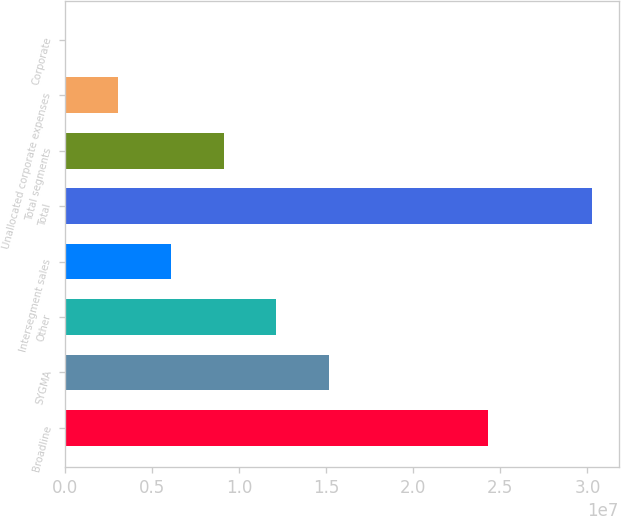Convert chart to OTSL. <chart><loc_0><loc_0><loc_500><loc_500><bar_chart><fcel>Broadline<fcel>SYGMA<fcel>Other<fcel>Intersegment sales<fcel>Total<fcel>Total segments<fcel>Unallocated corporate expenses<fcel>Corporate<nl><fcel>2.4267e+07<fcel>1.51597e+07<fcel>1.21353e+07<fcel>6.08642e+06<fcel>3.02819e+07<fcel>9.11085e+06<fcel>3.06198e+06<fcel>37543<nl></chart> 